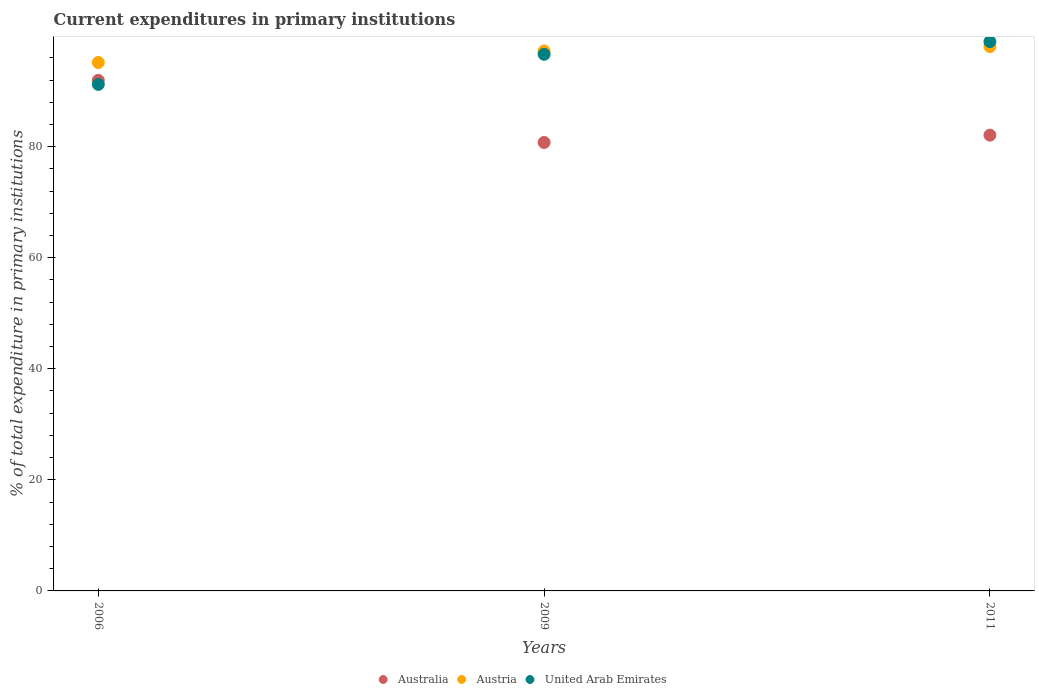How many different coloured dotlines are there?
Your answer should be compact. 3. What is the current expenditures in primary institutions in Australia in 2011?
Provide a short and direct response. 82.07. Across all years, what is the maximum current expenditures in primary institutions in United Arab Emirates?
Give a very brief answer. 98.91. Across all years, what is the minimum current expenditures in primary institutions in Australia?
Provide a succinct answer. 80.75. In which year was the current expenditures in primary institutions in Australia minimum?
Provide a succinct answer. 2009. What is the total current expenditures in primary institutions in Australia in the graph?
Your answer should be very brief. 254.76. What is the difference between the current expenditures in primary institutions in Australia in 2006 and that in 2011?
Your answer should be compact. 9.87. What is the difference between the current expenditures in primary institutions in Austria in 2011 and the current expenditures in primary institutions in United Arab Emirates in 2009?
Offer a very short reply. 1.39. What is the average current expenditures in primary institutions in Austria per year?
Offer a terse response. 96.8. In the year 2011, what is the difference between the current expenditures in primary institutions in Australia and current expenditures in primary institutions in United Arab Emirates?
Keep it short and to the point. -16.84. What is the ratio of the current expenditures in primary institutions in Australia in 2006 to that in 2011?
Your answer should be very brief. 1.12. Is the difference between the current expenditures in primary institutions in Australia in 2009 and 2011 greater than the difference between the current expenditures in primary institutions in United Arab Emirates in 2009 and 2011?
Provide a short and direct response. Yes. What is the difference between the highest and the second highest current expenditures in primary institutions in Australia?
Provide a short and direct response. 9.87. What is the difference between the highest and the lowest current expenditures in primary institutions in Australia?
Your response must be concise. 11.18. In how many years, is the current expenditures in primary institutions in United Arab Emirates greater than the average current expenditures in primary institutions in United Arab Emirates taken over all years?
Your response must be concise. 2. Is it the case that in every year, the sum of the current expenditures in primary institutions in Austria and current expenditures in primary institutions in Australia  is greater than the current expenditures in primary institutions in United Arab Emirates?
Provide a succinct answer. Yes. Is the current expenditures in primary institutions in United Arab Emirates strictly greater than the current expenditures in primary institutions in Austria over the years?
Your response must be concise. No. How many years are there in the graph?
Offer a very short reply. 3. Are the values on the major ticks of Y-axis written in scientific E-notation?
Give a very brief answer. No. Does the graph contain any zero values?
Make the answer very short. No. Where does the legend appear in the graph?
Provide a succinct answer. Bottom center. What is the title of the graph?
Your answer should be very brief. Current expenditures in primary institutions. Does "Cameroon" appear as one of the legend labels in the graph?
Provide a short and direct response. No. What is the label or title of the Y-axis?
Offer a very short reply. % of total expenditure in primary institutions. What is the % of total expenditure in primary institutions in Australia in 2006?
Give a very brief answer. 91.94. What is the % of total expenditure in primary institutions of Austria in 2006?
Offer a very short reply. 95.16. What is the % of total expenditure in primary institutions of United Arab Emirates in 2006?
Ensure brevity in your answer.  91.21. What is the % of total expenditure in primary institutions of Australia in 2009?
Provide a succinct answer. 80.75. What is the % of total expenditure in primary institutions in Austria in 2009?
Your response must be concise. 97.23. What is the % of total expenditure in primary institutions in United Arab Emirates in 2009?
Offer a very short reply. 96.63. What is the % of total expenditure in primary institutions in Australia in 2011?
Make the answer very short. 82.07. What is the % of total expenditure in primary institutions in Austria in 2011?
Your answer should be compact. 98.02. What is the % of total expenditure in primary institutions in United Arab Emirates in 2011?
Make the answer very short. 98.91. Across all years, what is the maximum % of total expenditure in primary institutions in Australia?
Provide a short and direct response. 91.94. Across all years, what is the maximum % of total expenditure in primary institutions in Austria?
Offer a terse response. 98.02. Across all years, what is the maximum % of total expenditure in primary institutions of United Arab Emirates?
Provide a succinct answer. 98.91. Across all years, what is the minimum % of total expenditure in primary institutions of Australia?
Ensure brevity in your answer.  80.75. Across all years, what is the minimum % of total expenditure in primary institutions of Austria?
Ensure brevity in your answer.  95.16. Across all years, what is the minimum % of total expenditure in primary institutions in United Arab Emirates?
Make the answer very short. 91.21. What is the total % of total expenditure in primary institutions in Australia in the graph?
Your response must be concise. 254.76. What is the total % of total expenditure in primary institutions of Austria in the graph?
Your answer should be very brief. 290.4. What is the total % of total expenditure in primary institutions of United Arab Emirates in the graph?
Keep it short and to the point. 286.75. What is the difference between the % of total expenditure in primary institutions of Australia in 2006 and that in 2009?
Your answer should be very brief. 11.18. What is the difference between the % of total expenditure in primary institutions in Austria in 2006 and that in 2009?
Ensure brevity in your answer.  -2.07. What is the difference between the % of total expenditure in primary institutions of United Arab Emirates in 2006 and that in 2009?
Give a very brief answer. -5.42. What is the difference between the % of total expenditure in primary institutions of Australia in 2006 and that in 2011?
Offer a terse response. 9.87. What is the difference between the % of total expenditure in primary institutions in Austria in 2006 and that in 2011?
Ensure brevity in your answer.  -2.86. What is the difference between the % of total expenditure in primary institutions in United Arab Emirates in 2006 and that in 2011?
Make the answer very short. -7.7. What is the difference between the % of total expenditure in primary institutions of Australia in 2009 and that in 2011?
Offer a very short reply. -1.31. What is the difference between the % of total expenditure in primary institutions of Austria in 2009 and that in 2011?
Give a very brief answer. -0.8. What is the difference between the % of total expenditure in primary institutions in United Arab Emirates in 2009 and that in 2011?
Offer a very short reply. -2.28. What is the difference between the % of total expenditure in primary institutions in Australia in 2006 and the % of total expenditure in primary institutions in Austria in 2009?
Provide a succinct answer. -5.29. What is the difference between the % of total expenditure in primary institutions in Australia in 2006 and the % of total expenditure in primary institutions in United Arab Emirates in 2009?
Provide a short and direct response. -4.69. What is the difference between the % of total expenditure in primary institutions of Austria in 2006 and the % of total expenditure in primary institutions of United Arab Emirates in 2009?
Your answer should be compact. -1.47. What is the difference between the % of total expenditure in primary institutions of Australia in 2006 and the % of total expenditure in primary institutions of Austria in 2011?
Keep it short and to the point. -6.08. What is the difference between the % of total expenditure in primary institutions in Australia in 2006 and the % of total expenditure in primary institutions in United Arab Emirates in 2011?
Offer a terse response. -6.97. What is the difference between the % of total expenditure in primary institutions in Austria in 2006 and the % of total expenditure in primary institutions in United Arab Emirates in 2011?
Give a very brief answer. -3.76. What is the difference between the % of total expenditure in primary institutions in Australia in 2009 and the % of total expenditure in primary institutions in Austria in 2011?
Offer a terse response. -17.27. What is the difference between the % of total expenditure in primary institutions of Australia in 2009 and the % of total expenditure in primary institutions of United Arab Emirates in 2011?
Provide a short and direct response. -18.16. What is the difference between the % of total expenditure in primary institutions of Austria in 2009 and the % of total expenditure in primary institutions of United Arab Emirates in 2011?
Offer a terse response. -1.69. What is the average % of total expenditure in primary institutions of Australia per year?
Make the answer very short. 84.92. What is the average % of total expenditure in primary institutions in Austria per year?
Keep it short and to the point. 96.8. What is the average % of total expenditure in primary institutions of United Arab Emirates per year?
Offer a terse response. 95.58. In the year 2006, what is the difference between the % of total expenditure in primary institutions in Australia and % of total expenditure in primary institutions in Austria?
Offer a very short reply. -3.22. In the year 2006, what is the difference between the % of total expenditure in primary institutions of Australia and % of total expenditure in primary institutions of United Arab Emirates?
Ensure brevity in your answer.  0.73. In the year 2006, what is the difference between the % of total expenditure in primary institutions in Austria and % of total expenditure in primary institutions in United Arab Emirates?
Offer a terse response. 3.95. In the year 2009, what is the difference between the % of total expenditure in primary institutions in Australia and % of total expenditure in primary institutions in Austria?
Make the answer very short. -16.47. In the year 2009, what is the difference between the % of total expenditure in primary institutions of Australia and % of total expenditure in primary institutions of United Arab Emirates?
Give a very brief answer. -15.87. In the year 2009, what is the difference between the % of total expenditure in primary institutions of Austria and % of total expenditure in primary institutions of United Arab Emirates?
Provide a short and direct response. 0.6. In the year 2011, what is the difference between the % of total expenditure in primary institutions of Australia and % of total expenditure in primary institutions of Austria?
Ensure brevity in your answer.  -15.95. In the year 2011, what is the difference between the % of total expenditure in primary institutions of Australia and % of total expenditure in primary institutions of United Arab Emirates?
Your response must be concise. -16.84. In the year 2011, what is the difference between the % of total expenditure in primary institutions of Austria and % of total expenditure in primary institutions of United Arab Emirates?
Your answer should be very brief. -0.89. What is the ratio of the % of total expenditure in primary institutions in Australia in 2006 to that in 2009?
Give a very brief answer. 1.14. What is the ratio of the % of total expenditure in primary institutions of Austria in 2006 to that in 2009?
Offer a terse response. 0.98. What is the ratio of the % of total expenditure in primary institutions in United Arab Emirates in 2006 to that in 2009?
Give a very brief answer. 0.94. What is the ratio of the % of total expenditure in primary institutions in Australia in 2006 to that in 2011?
Keep it short and to the point. 1.12. What is the ratio of the % of total expenditure in primary institutions in Austria in 2006 to that in 2011?
Offer a terse response. 0.97. What is the ratio of the % of total expenditure in primary institutions of United Arab Emirates in 2006 to that in 2011?
Ensure brevity in your answer.  0.92. What is the ratio of the % of total expenditure in primary institutions in United Arab Emirates in 2009 to that in 2011?
Give a very brief answer. 0.98. What is the difference between the highest and the second highest % of total expenditure in primary institutions in Australia?
Provide a succinct answer. 9.87. What is the difference between the highest and the second highest % of total expenditure in primary institutions of Austria?
Provide a succinct answer. 0.8. What is the difference between the highest and the second highest % of total expenditure in primary institutions of United Arab Emirates?
Offer a terse response. 2.28. What is the difference between the highest and the lowest % of total expenditure in primary institutions of Australia?
Your answer should be compact. 11.18. What is the difference between the highest and the lowest % of total expenditure in primary institutions of Austria?
Your answer should be very brief. 2.86. What is the difference between the highest and the lowest % of total expenditure in primary institutions of United Arab Emirates?
Your response must be concise. 7.7. 